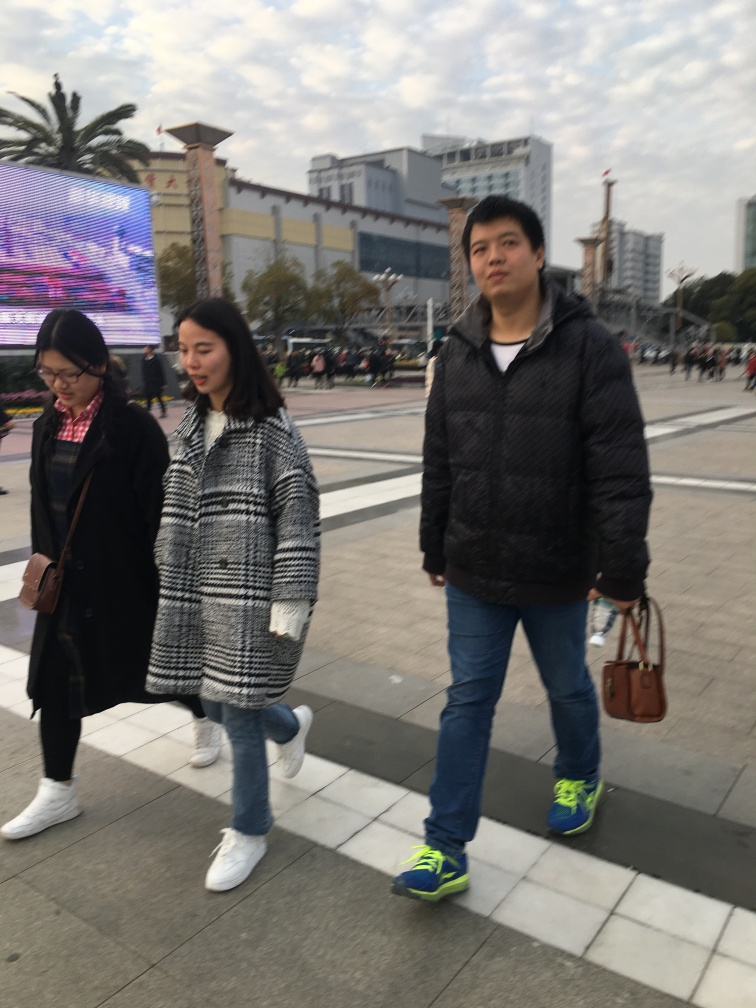Describe the focus of the photo.
A. The focus is partially clear, partially blurry.
B. The focus is very clear.
C. The focus is completely out of focus. The focus within the photo appears to be intentionally selective, with the foreground subject, a person, being in clear focus, while the background and peripheral areas exhibit a noticeable blur. This technique often emphasizes the subject and adds depth to the photograph. 